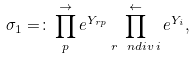<formula> <loc_0><loc_0><loc_500><loc_500>\sigma _ { 1 } = \colon \prod ^ { \rightarrow } _ { p } e ^ { Y _ { r p } } \prod _ { r \, \ n d i v \, i } ^ { \leftarrow } e ^ { Y _ { i } } ,</formula> 